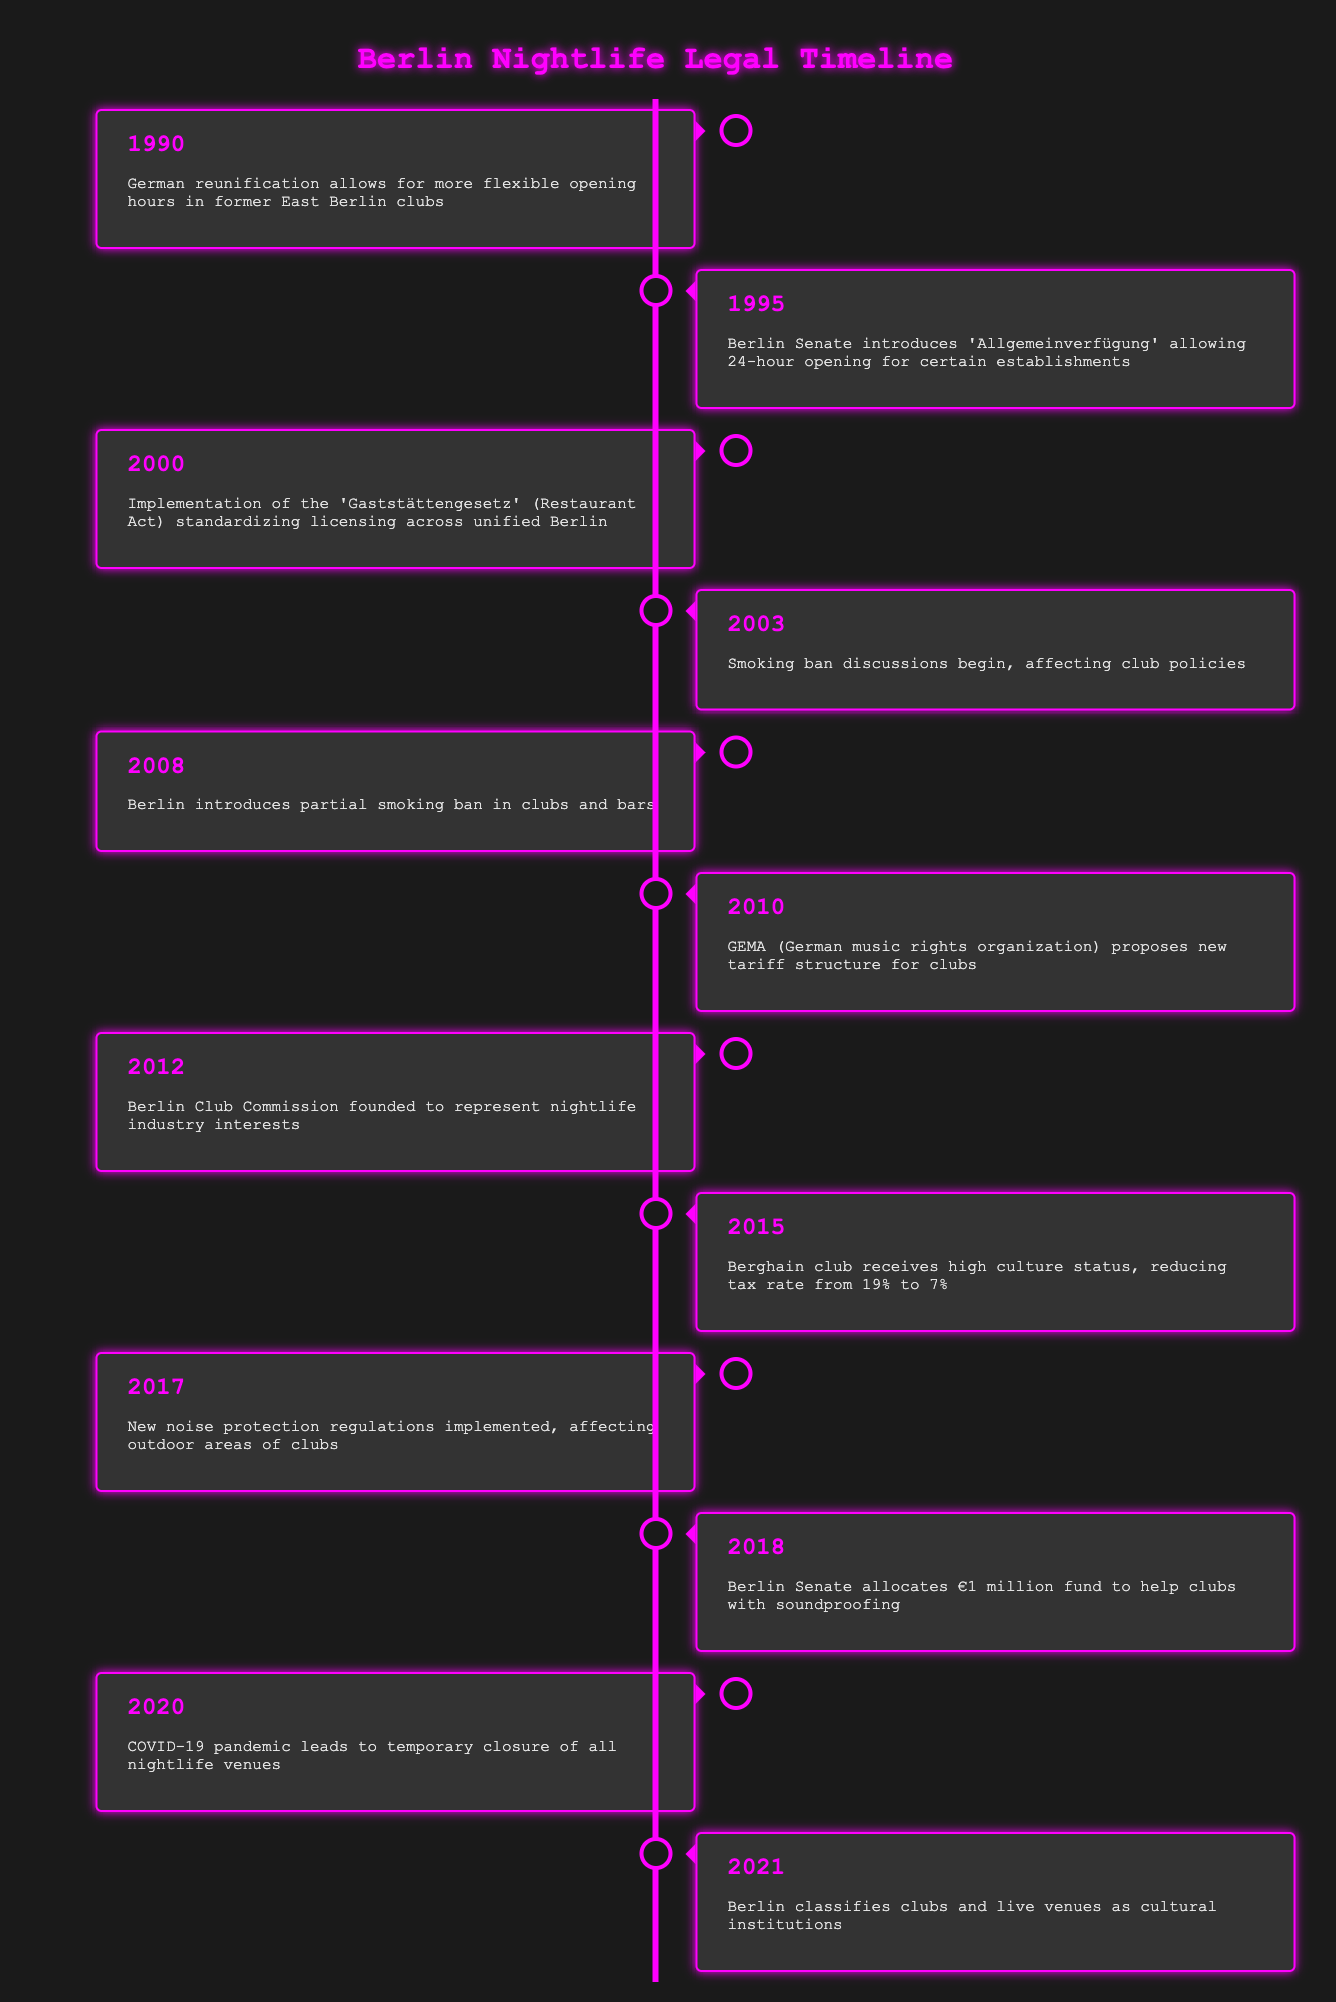What significant legal change occurred in 2000? The specific event listed for the year 2000 is the implementation of the 'Gaststättengesetz' (Restaurant Act). This act standardized licensing across unified Berlin, which is a key change in the legal landscape for nightlife.
Answer: Implementation of the 'Gaststättengesetz' (Restaurant Act) Was there a smoking ban discussed before the partial smoking ban in 2008? The table indicates that discussions about a smoking ban began in 2003, which is before the introduction of the partial smoking ban in 2008. Therefore, the answer is yes, there were discussions.
Answer: Yes How many years passed between the German reunification in 1990 and the classification of clubs as cultural institutions in 2021? To determine the number of years between 1990 and 2021, subtract the earlier year from the later year: 2021 - 1990 = 31 years. Thus, 31 years passed between these two events.
Answer: 31 years What action did the Berlin Senate take in 2018 to support clubs? In 2018, the Berlin Senate allocated a €1 million fund specifically to help clubs with soundproofing, which is a direct support measure for the nightlife industry.
Answer: Allocated €1 million fund for soundproofing Did the introduction of new noise protection regulations in 2017 increase support for outdoor areas of clubs? The introduction of new noise protection regulations in 2017 limited the noise from clubs affecting outdoor areas, which suggests an increase in regulations rather than direct support, thus the answer would be no.
Answer: No Which year saw the introduction of 24-hour opening hours for certain establishments? According to the table, the year 1995 saw the Berlin Senate introduce the 'Allgemeinverfügung' allowing for 24-hour opening for certain establishments, making it a notable event in the nightlife timeline.
Answer: 1995 How did the status of Berghain club change in 2015? In 2015, the Berghain club received high culture status, resulting in a reduction of its tax rate from 19% to 7%, indicating a significant shift in its legal recognition and financial burden.
Answer: Received high culture status, tax reduced to 7% What event in 2020 significantly impacted all nightlife venues in Berlin? The table states that in 2020, the COVID-19 pandemic led to the temporary closure of all nightlife venues. This was a critical event that affected the entire industry.
Answer: Temporary closure due to COVID-19 pandemic 